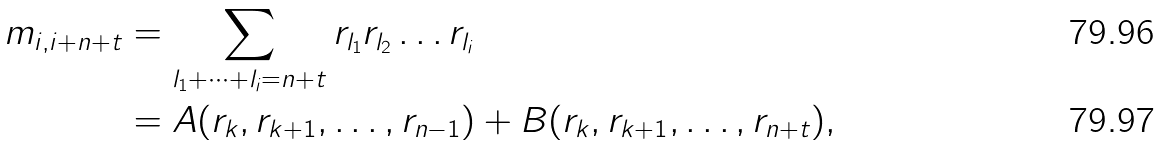Convert formula to latex. <formula><loc_0><loc_0><loc_500><loc_500>m _ { i , i + n + t } & = \sum _ { l _ { 1 } + \cdots + l _ { i } = n + t } r _ { l _ { 1 } } r _ { l _ { 2 } } \dots r _ { l _ { i } } \\ & = A ( r _ { k } , r _ { k + 1 } , \dots , r _ { n - 1 } ) + B ( r _ { k } , r _ { k + 1 } , \dots , r _ { n + t } ) ,</formula> 